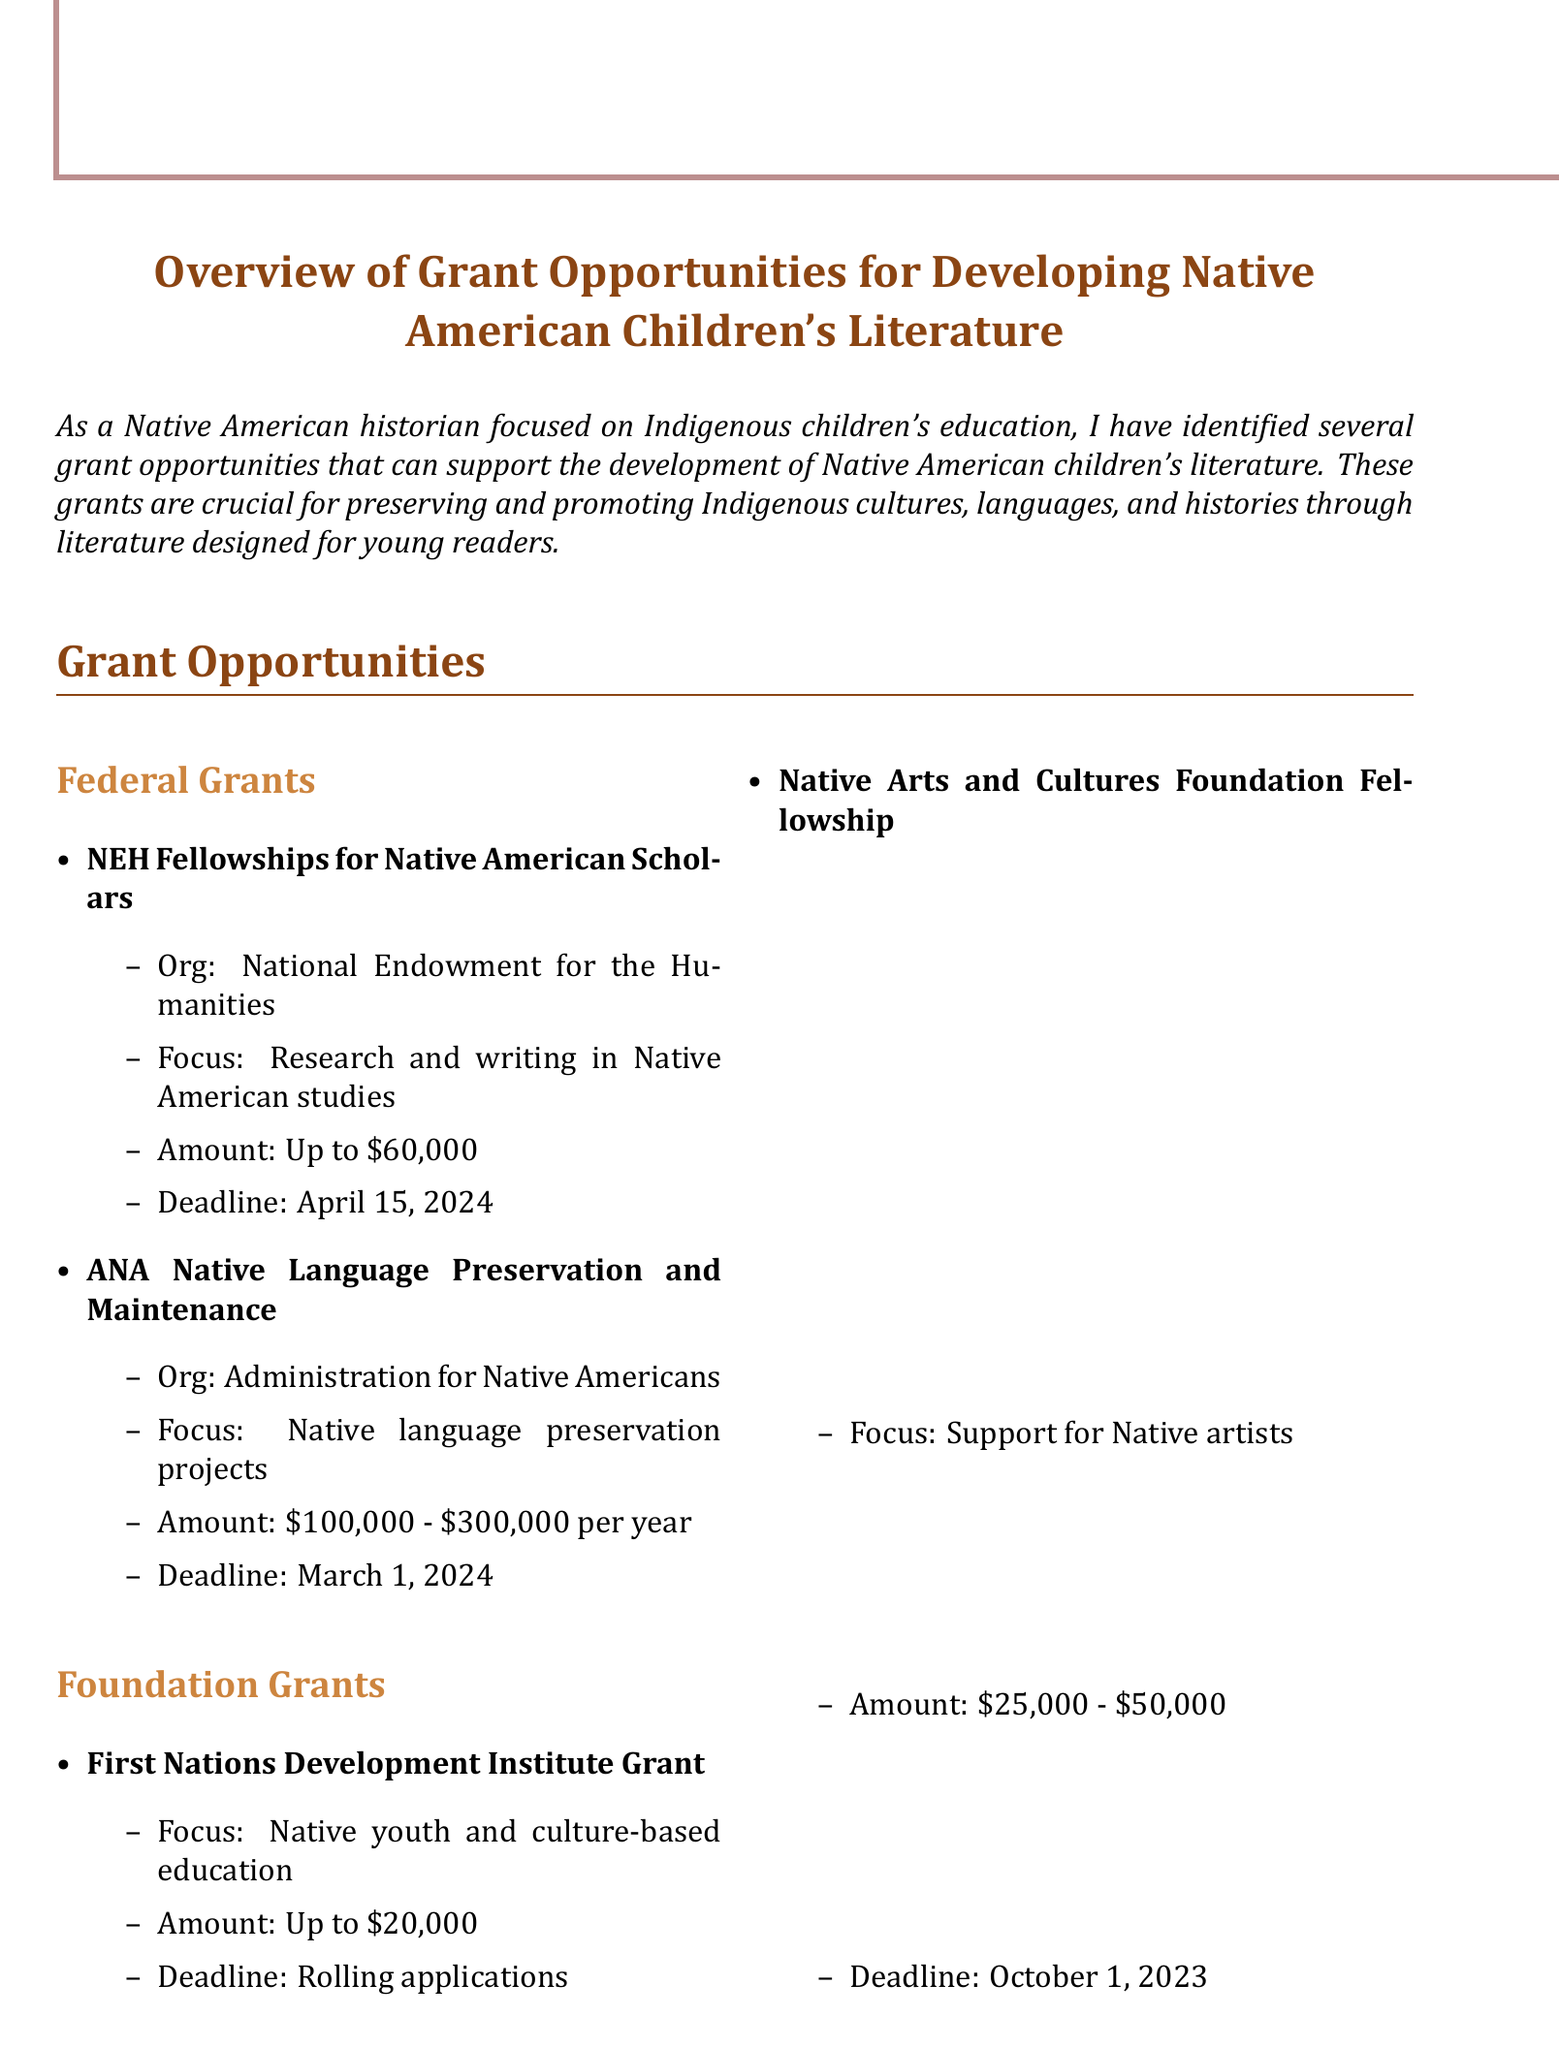What is the title of the memo? The title of the memo is explicitly stated at the beginning as "Overview of Grant Opportunities for Developing Native American Children's Literature."
Answer: Overview of Grant Opportunities for Developing Native American Children's Literature What is the deadline for the NEH Fellowships grant? The grant deadlines are specified for each opportunity, and the NEH Fellowships has a deadline of April 15, 2024.
Answer: April 15, 2024 What is the amount available for the ANA Native Language Preservation and Maintenance grant? The document states that the ANA grant offers an amount ranging from $100,000 to $300,000 per year.
Answer: $100,000 - $300,000 per year What type of projects does the First Nations Development Institute Grant support? The focus of the First Nations Development Institute Grant is highlighted in the document as Native youth and culture-based education projects.
Answer: Native youth and culture-based education projects Which publisher initiative offers a cash prize? The document details various initiatives, and the Lee & Low Books New Voices Award specifically offers a cash prize of $2,000.
Answer: Lee & Low Books New Voices Award What action is recommended to engage with tribal education departments? The document suggests several recommended actions, and one of them is to engage with tribal education departments for support and partnerships.
Answer: Engage with tribal education departments for support What is the total amount offered for the Native Arts and Cultures Foundation Fellowship? The fellowship offers a range for funding, which is stated as $25,000 to $50,000.
Answer: $25,000 - $50,000 What is the purpose of the Navajo Nation Library System Grant? The document clarifies that the purpose of the Navajo Nation Library System Grant is to support the development of Navajo language children's books.
Answer: Development of Navajo language children's books What is a recommended action for project proposals? The memo explicitly recommends preparing project proposals aligned with the grant objectives.
Answer: Prepare project proposals aligned with grant objectives 